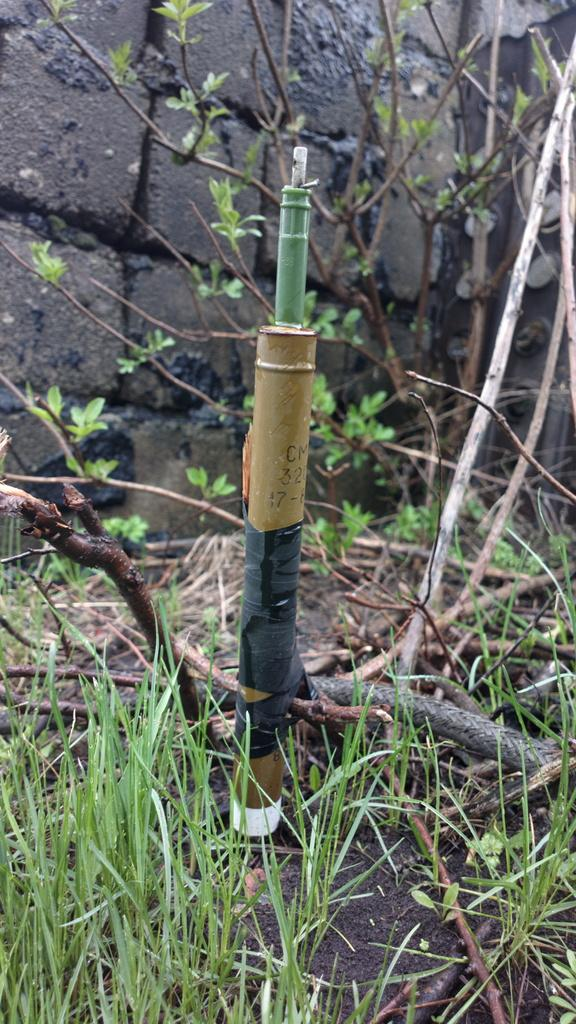What is the main object in the image? There is a sprinkler in the image. What else can be seen in the image besides the sprinkler? There are plants and grass in the image. What is visible in the background of the image? There is a wall in the background of the image. Where are the cherries growing in the image? There are no cherries present in the image. What type of beggar can be seen in the image? There is no beggar present in the image. 